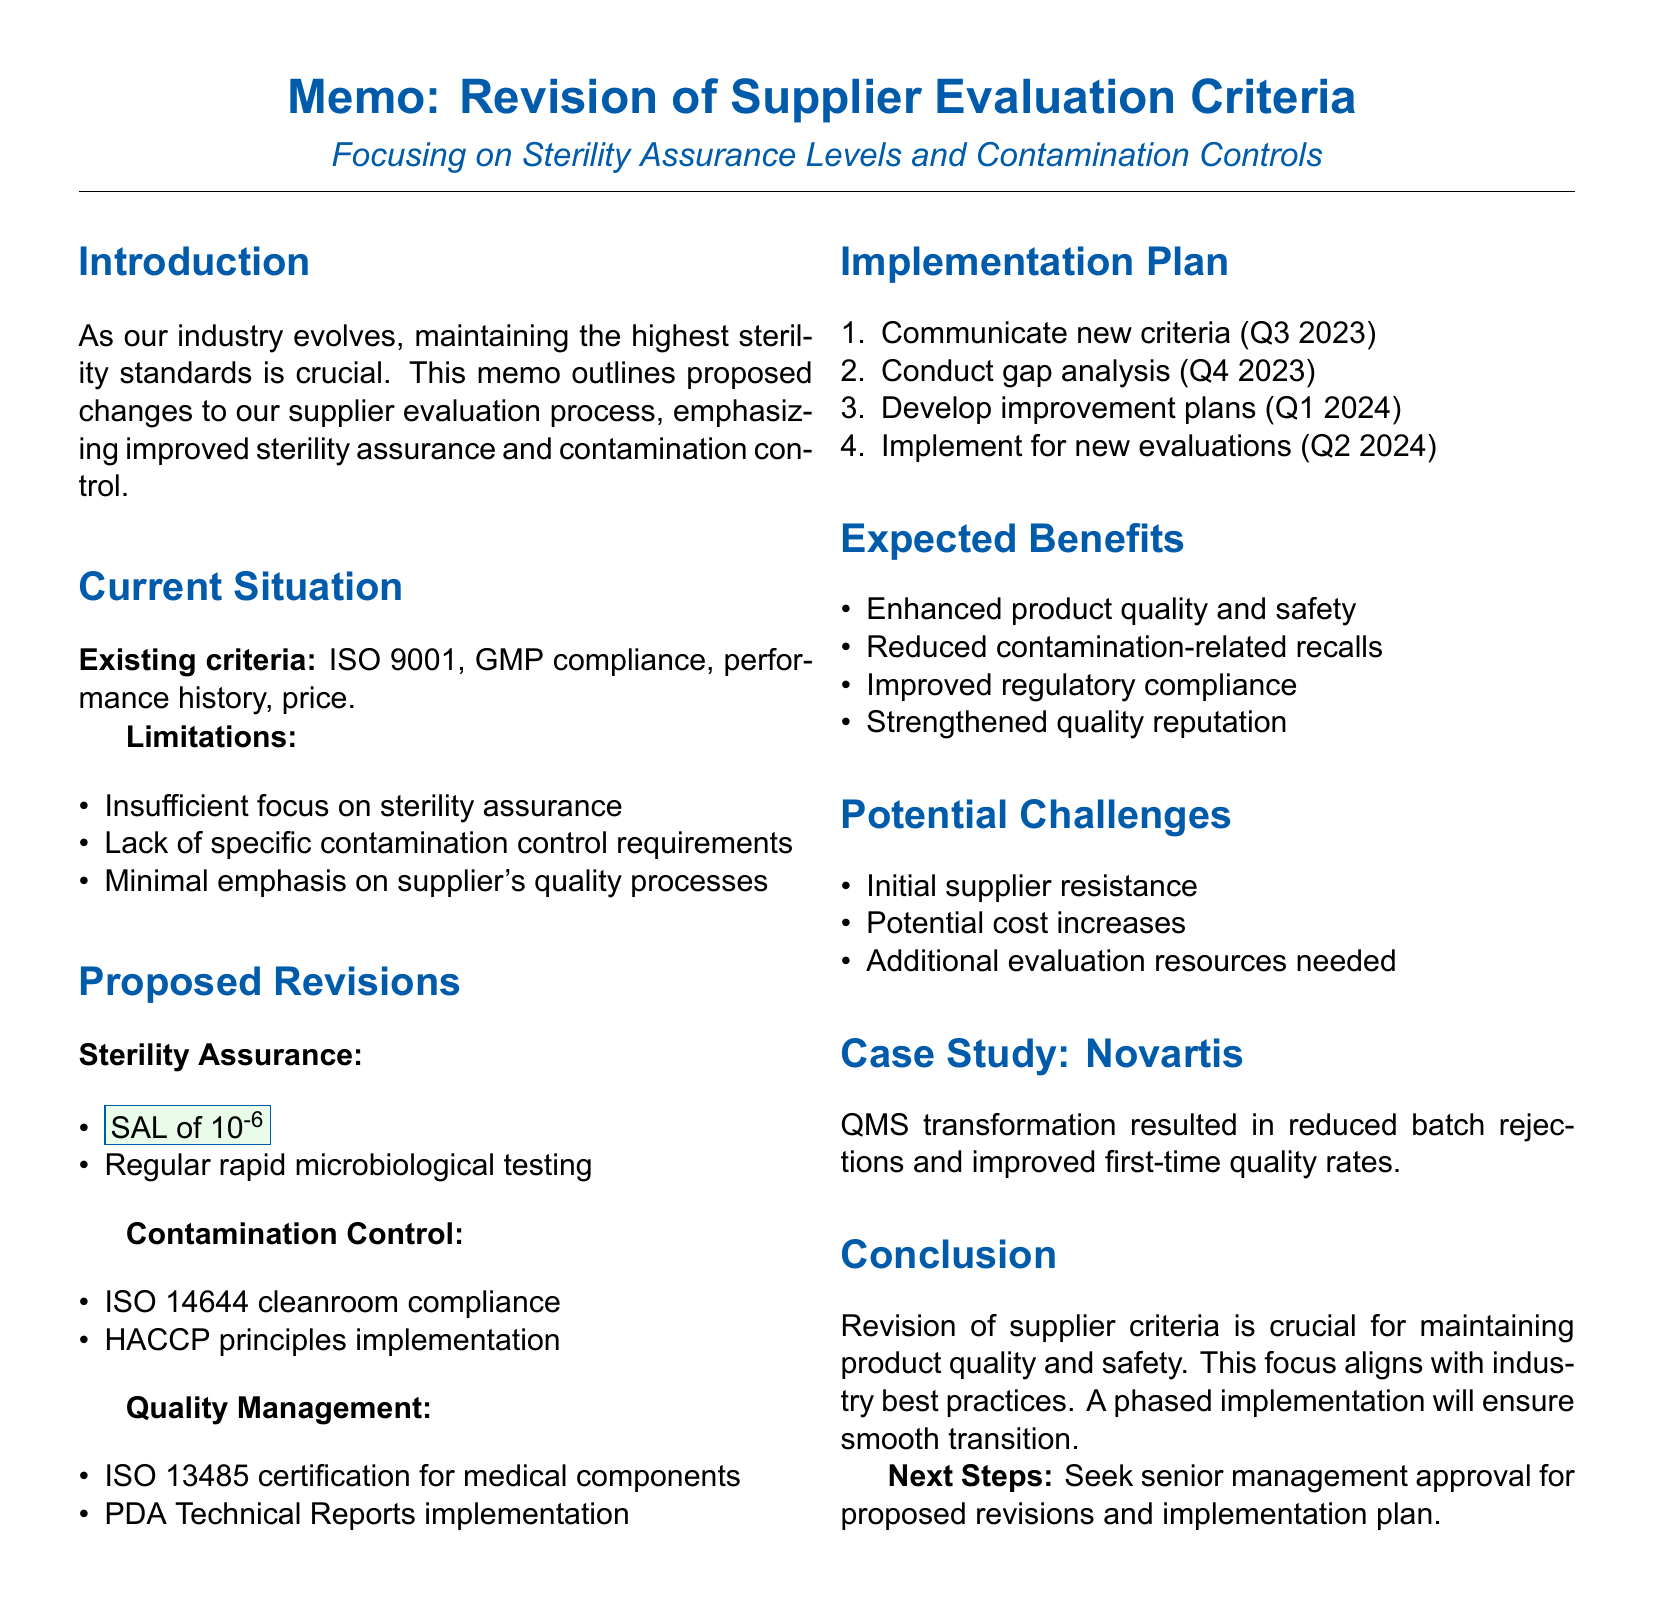what is the title of the memo? The title of the memo is explicitly mentioned at the beginning, indicating the subject matter.
Answer: Revision of Supplier Evaluation Criteria for Raw Materials: Focusing on Sterility Assurance Levels and Contamination Controls what is the timeline for phase 1 of the implementation plan? The timeline for phase 1 of the implementation plan specifies when the action should take place.
Answer: Q3 2023 what is one limitation of the existing supplier evaluation criteria? The document lists several limitations and one is specified as a key point.
Answer: Insufficient focus on sterility assurance levels which certification is being proposed for medical device components? The proposed revision includes a specific certification mentioned for medical device components.
Answer: ISO 13485 certification what is the rationale for implementing HACCP principles? The document provides a rationale for this specific criterion regarding contamination control.
Answer: Proactive approach to identifying and mitigating contamination risks how many phases are outlined in the implementation plan? The implementation plan is organized into distinct phases that are numbered.
Answer: 4 what is one expected benefit of the proposed revisions? The document enumerates several expected benefits from the proposed changes.
Answer: Enhanced product quality and safety who is mentioned in the case study? This reference in the case study highlights a company's initiative relevant to the document's content.
Answer: Novartis what is the key focus of the proposed revisions? The memo highlights what the proposed changes primarily address.
Answer: Sterility assurance and contamination control 